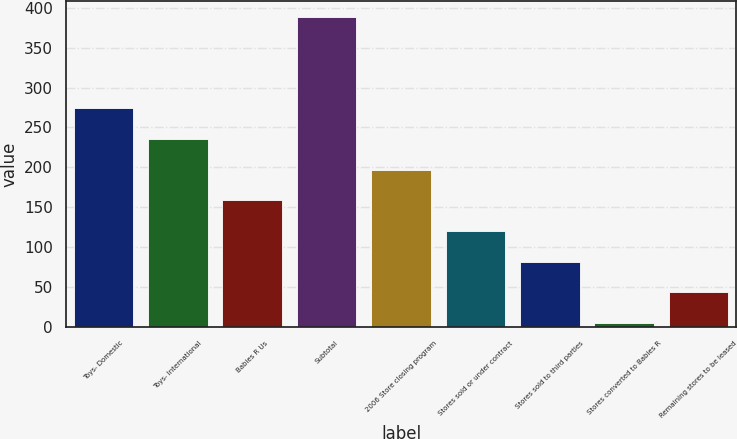Convert chart. <chart><loc_0><loc_0><loc_500><loc_500><bar_chart><fcel>Toys- Domestic<fcel>Toys- International<fcel>Babies R Us<fcel>Subtotal<fcel>2006 Store closing program<fcel>Stores sold or under contract<fcel>Stores sold to third parties<fcel>Stores converted to Babies R<fcel>Remaining stores to be leased<nl><fcel>273.8<fcel>235.4<fcel>158.6<fcel>389<fcel>197<fcel>120.2<fcel>81.8<fcel>5<fcel>43.4<nl></chart> 